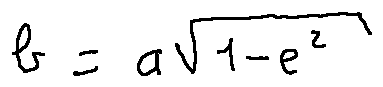<formula> <loc_0><loc_0><loc_500><loc_500>b = a \sqrt { 1 - e ^ { 2 } }</formula> 